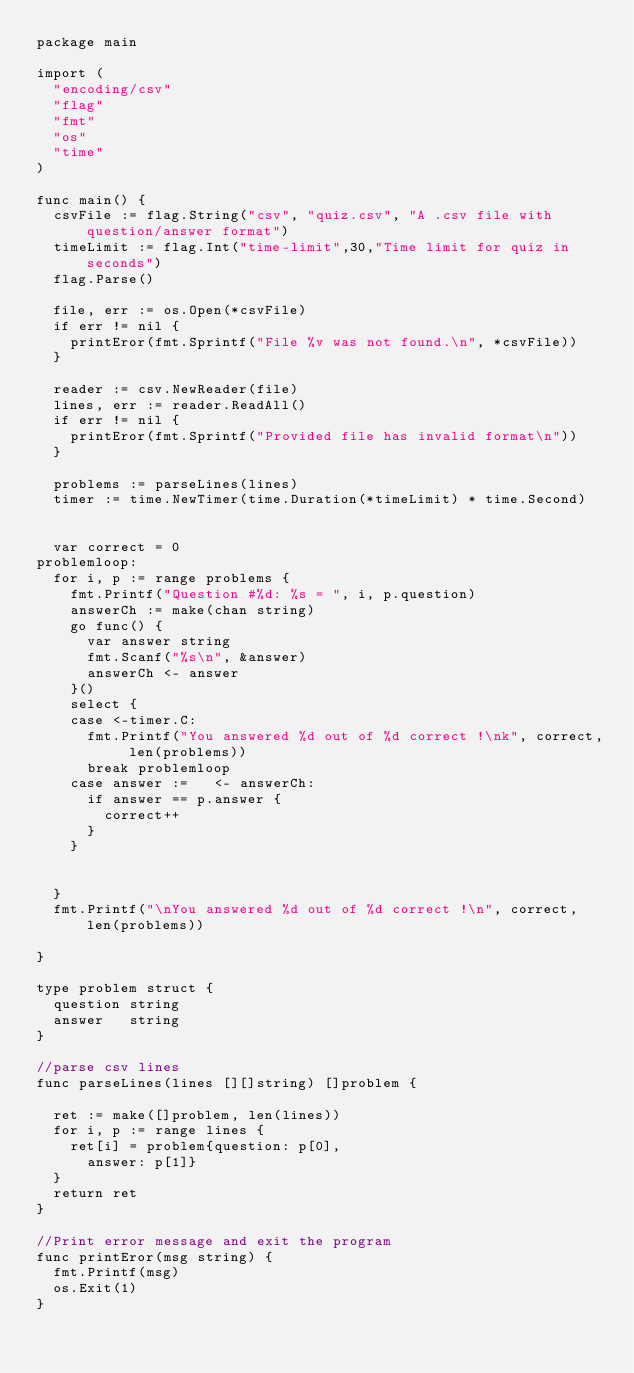Convert code to text. <code><loc_0><loc_0><loc_500><loc_500><_Go_>package main

import (
	"encoding/csv"
	"flag"
	"fmt"
	"os"
	"time"
)

func main() {
	csvFile := flag.String("csv", "quiz.csv", "A .csv file with question/answer format")
	timeLimit := flag.Int("time-limit",30,"Time limit for quiz in seconds")
	flag.Parse()

	file, err := os.Open(*csvFile)
	if err != nil {
		printEror(fmt.Sprintf("File %v was not found.\n", *csvFile))
	}

	reader := csv.NewReader(file)
	lines, err := reader.ReadAll()
	if err != nil {
		printEror(fmt.Sprintf("Provided file has invalid format\n"))
	}

	problems := parseLines(lines)
	timer := time.NewTimer(time.Duration(*timeLimit) * time.Second)


	var correct = 0
problemloop:
	for i, p := range problems {
		fmt.Printf("Question #%d: %s = ", i, p.question)
		answerCh := make(chan string)
		go func() {
			var answer string
			fmt.Scanf("%s\n", &answer)
			answerCh <- answer
		}()
		select {
		case <-timer.C:
			fmt.Printf("You answered %d out of %d correct !\nk", correct, len(problems))
			break problemloop
		case answer :=   <- answerCh:
			if answer == p.answer {
				correct++
			}
		}


	}
	fmt.Printf("\nYou answered %d out of %d correct !\n", correct, len(problems))

}

type problem struct {
	question string
	answer   string
}

//parse csv lines
func parseLines(lines [][]string) []problem {

	ret := make([]problem, len(lines))
	for i, p := range lines {
		ret[i] = problem{question: p[0],
			answer: p[1]}
	}
	return ret
}

//Print error message and exit the program
func printEror(msg string) {
	fmt.Printf(msg)
	os.Exit(1)
}



</code> 